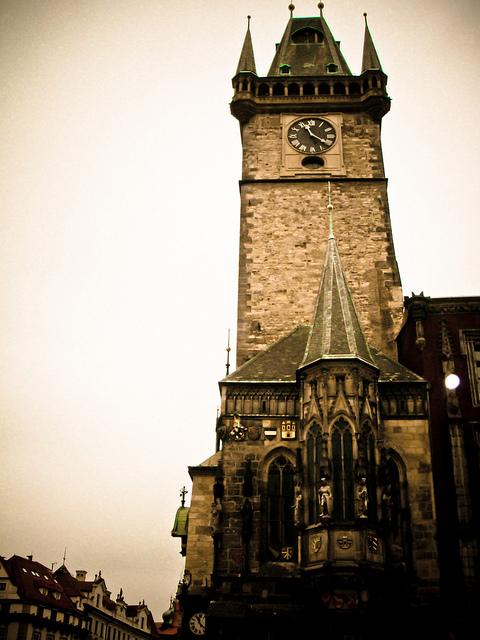How many spires does the building have?
Quick response, please. 3. What does the clock read?
Concise answer only. 11:20. Is this building tall?
Quick response, please. Yes. 